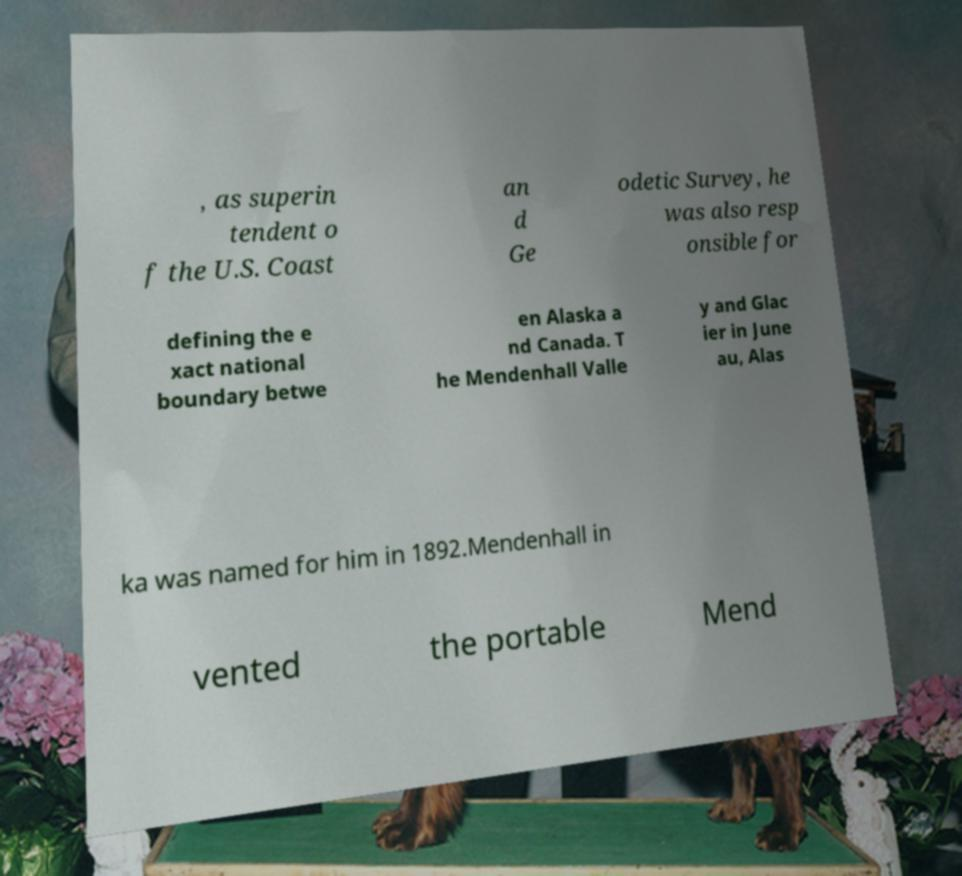For documentation purposes, I need the text within this image transcribed. Could you provide that? , as superin tendent o f the U.S. Coast an d Ge odetic Survey, he was also resp onsible for defining the e xact national boundary betwe en Alaska a nd Canada. T he Mendenhall Valle y and Glac ier in June au, Alas ka was named for him in 1892.Mendenhall in vented the portable Mend 